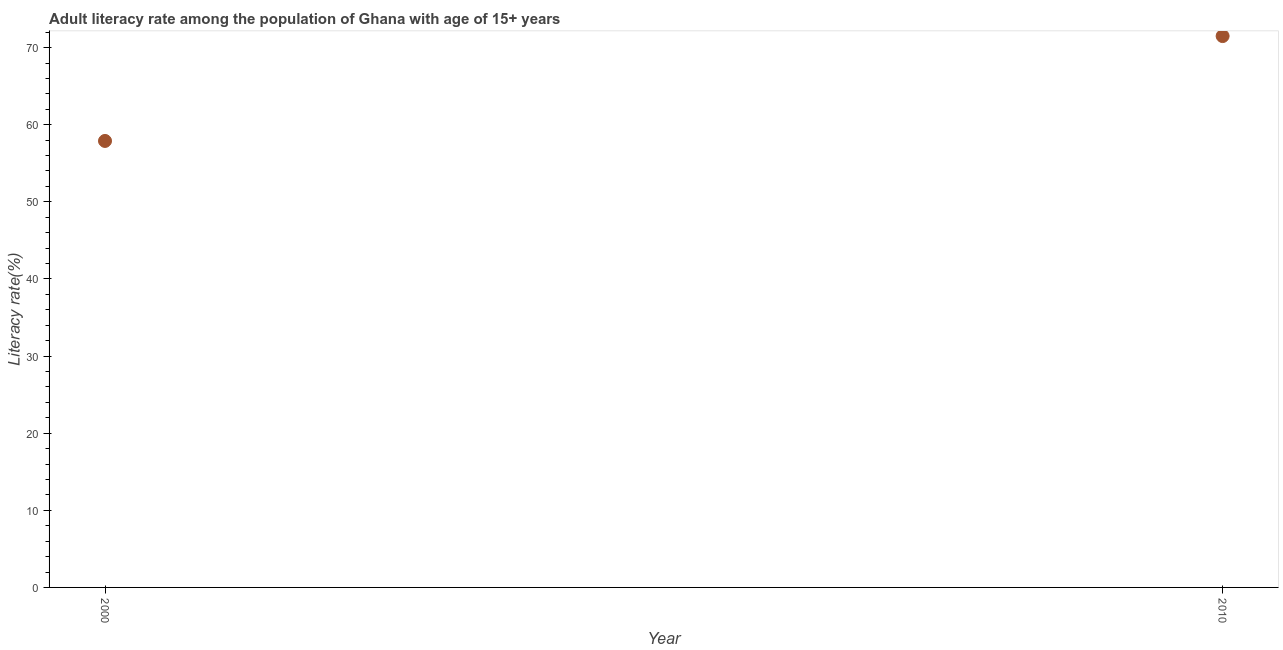What is the adult literacy rate in 2000?
Provide a short and direct response. 57.9. Across all years, what is the maximum adult literacy rate?
Your answer should be very brief. 71.5. Across all years, what is the minimum adult literacy rate?
Your response must be concise. 57.9. What is the sum of the adult literacy rate?
Offer a very short reply. 129.39. What is the difference between the adult literacy rate in 2000 and 2010?
Your answer should be very brief. -13.6. What is the average adult literacy rate per year?
Provide a short and direct response. 64.7. What is the median adult literacy rate?
Provide a short and direct response. 64.7. What is the ratio of the adult literacy rate in 2000 to that in 2010?
Your answer should be very brief. 0.81. Is the adult literacy rate in 2000 less than that in 2010?
Provide a succinct answer. Yes. In how many years, is the adult literacy rate greater than the average adult literacy rate taken over all years?
Offer a very short reply. 1. How many dotlines are there?
Give a very brief answer. 1. Are the values on the major ticks of Y-axis written in scientific E-notation?
Provide a short and direct response. No. Does the graph contain any zero values?
Your answer should be very brief. No. Does the graph contain grids?
Ensure brevity in your answer.  No. What is the title of the graph?
Give a very brief answer. Adult literacy rate among the population of Ghana with age of 15+ years. What is the label or title of the Y-axis?
Offer a terse response. Literacy rate(%). What is the Literacy rate(%) in 2000?
Offer a terse response. 57.9. What is the Literacy rate(%) in 2010?
Your answer should be compact. 71.5. What is the difference between the Literacy rate(%) in 2000 and 2010?
Provide a succinct answer. -13.6. What is the ratio of the Literacy rate(%) in 2000 to that in 2010?
Give a very brief answer. 0.81. 